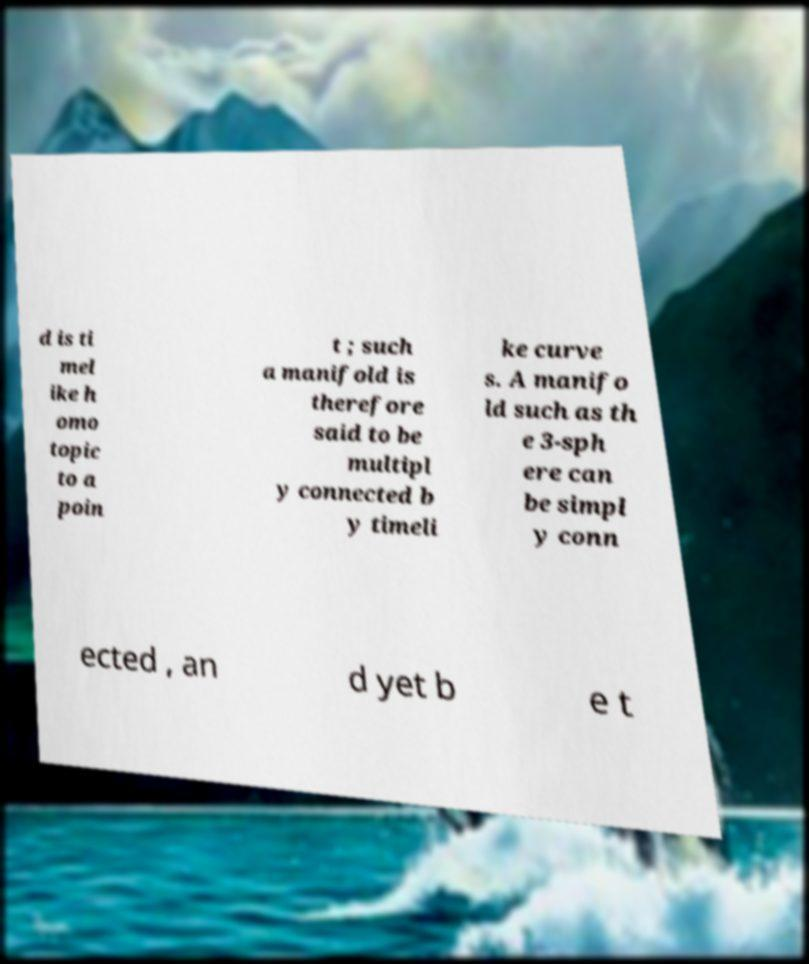There's text embedded in this image that I need extracted. Can you transcribe it verbatim? d is ti mel ike h omo topic to a poin t ; such a manifold is therefore said to be multipl y connected b y timeli ke curve s. A manifo ld such as th e 3-sph ere can be simpl y conn ected , an d yet b e t 